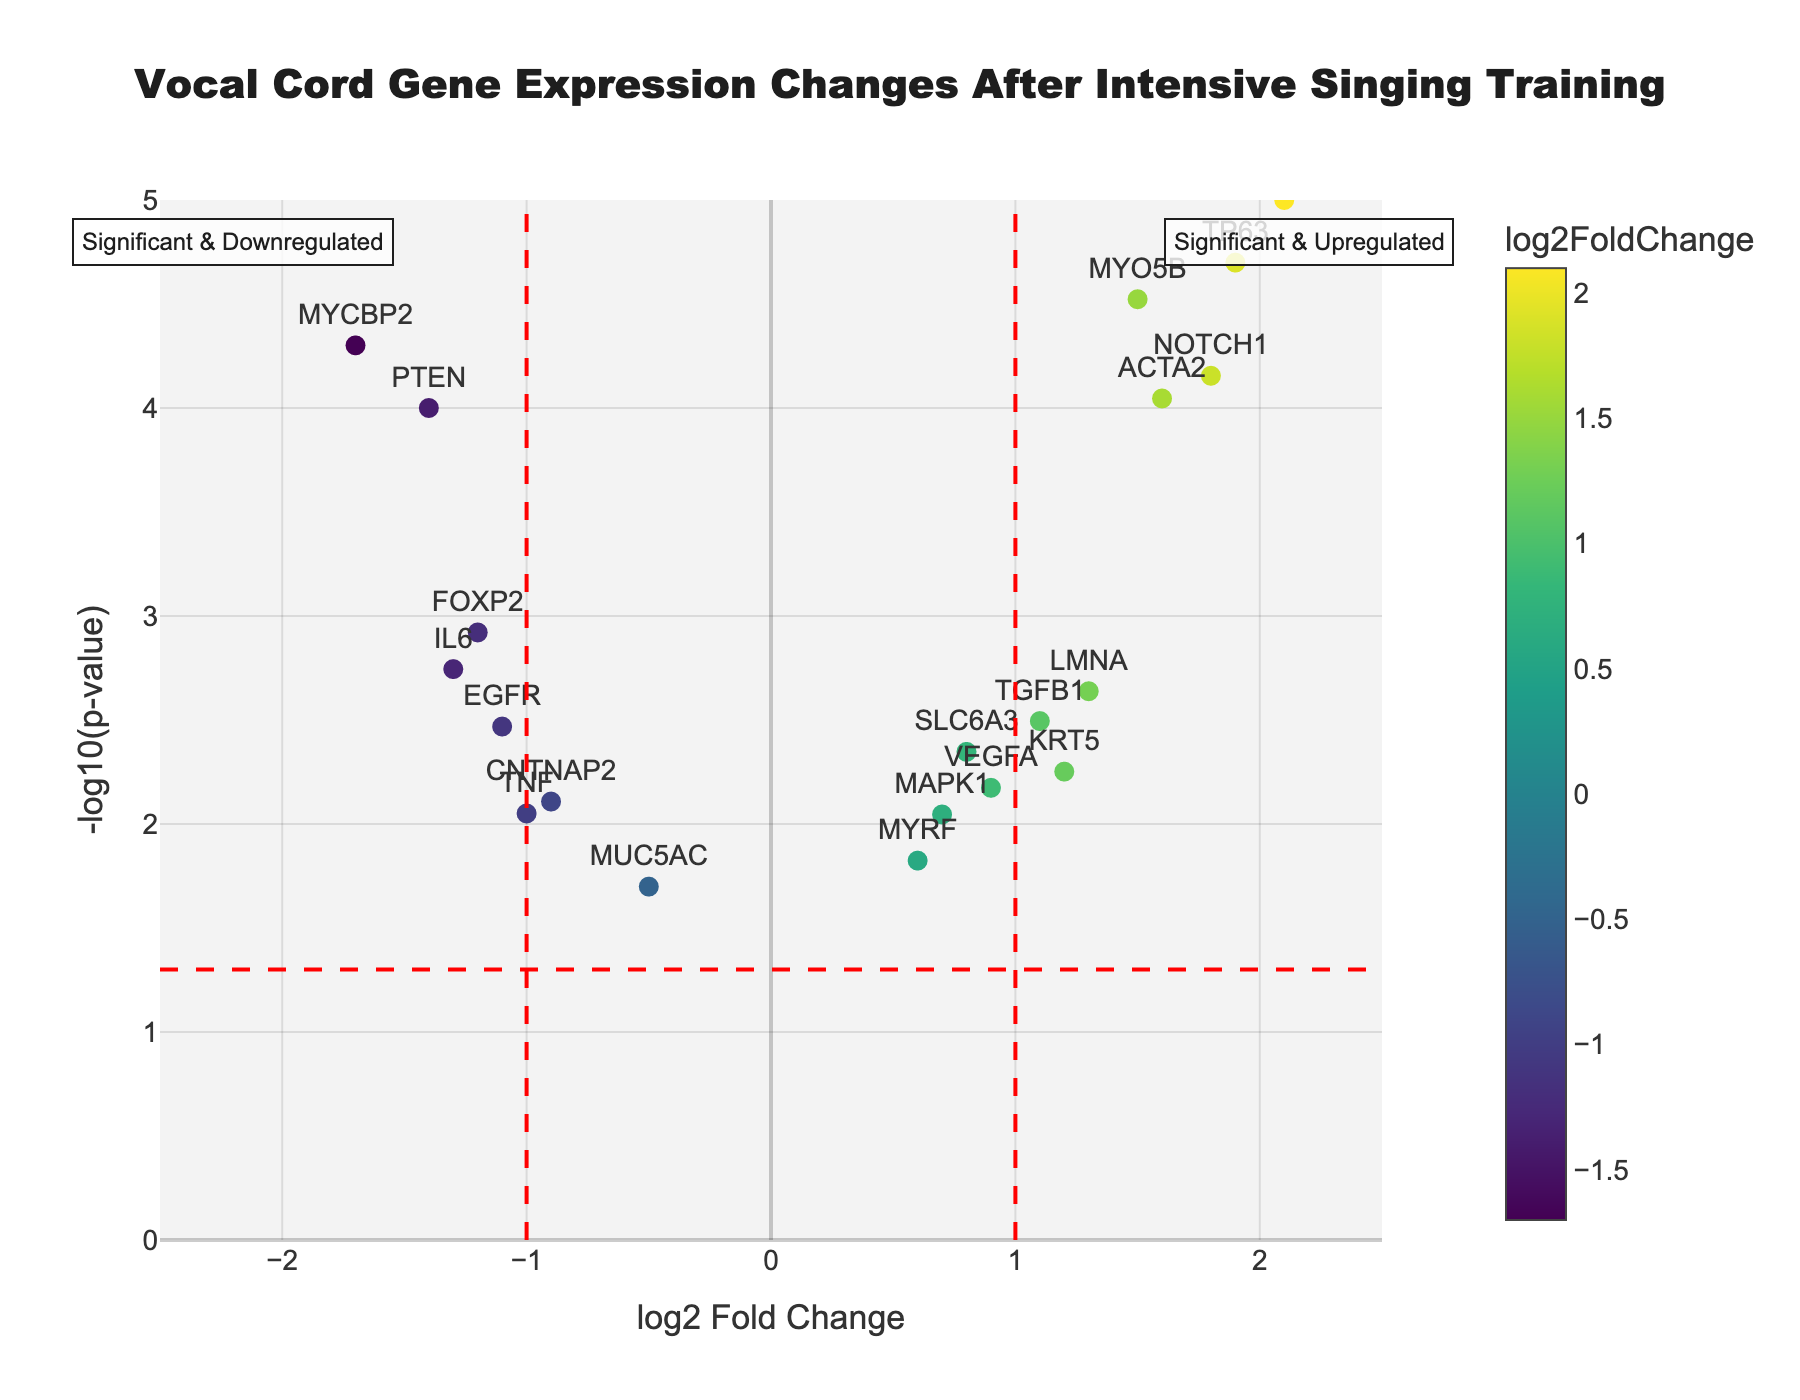What does the title of the figure indicate? The title of the figure is "Vocal Cord Gene Expression Changes After Intensive Singing Training," which indicates that the plot is analyzing how gene expression levels in vocal cord tissue change due to intensive singing training. It implies a focus on differences before and after the training.
Answer: Vocal Cord Gene Expression Changes After Intensive Singing Training Which gene has the highest log2 fold change? The highest log2 fold change can be identified by looking for the data point farthest to the right on the x-axis. The gene with the highest log2 fold change is COL1A1, with a log2 fold change of 2.1.
Answer: COL1A1 How many genes show significant upregulation according to the plot? Significant upregulation is typically indicated by points on the right side of the red vertical lines (log2FC > 1) and above the red horizontal line, indicating a p-value less than 0.05. The significantly upregulated genes are MYO5B, COL1A1, LMNA, NOTCH1, TP63, ACTA2, and TGFB1, totaling 7 genes.
Answer: 7 Which gene has the smallest p-value, and what is its log2 fold change? The gene with the smallest p-value will be the data point highest on the y-axis. The gene MYO5B has the smallest p-value (3.00E-05) with a log2 fold change of 1.5.
Answer: MYO5B, 1.5 What does the color of the data points represent? The color of the data points represents the log2FoldChange values, with a colorscale (Viridis) applied to visually differentiate the values.
Answer: log2FoldChange values Which genes are located in the "Significant & Downregulated" region? The "Significant & Downregulated" region is to the left of the red vertical line at log2FC = -1 and above the red horizontal line. The genes in this region are FOXP2, MYCBP2, PTEN, and IL6.
Answer: FOXP2, MYCBP2, PTEN, IL6 What is the log2 fold change for the gene with the highest significance? The gene with the highest significance is identified by the highest -log10(p-value), which is MYO5B with a log2 fold change of 1.5.
Answer: 1.5 Are there any genes with a log2 fold change between -0.5 and 0.5? To find genes within this range, we look for points within the specified interval on the x-axis. The gene MUC5AC has a log2 fold change of -0.5, which fits this criteria.
Answer: MUC5AC 